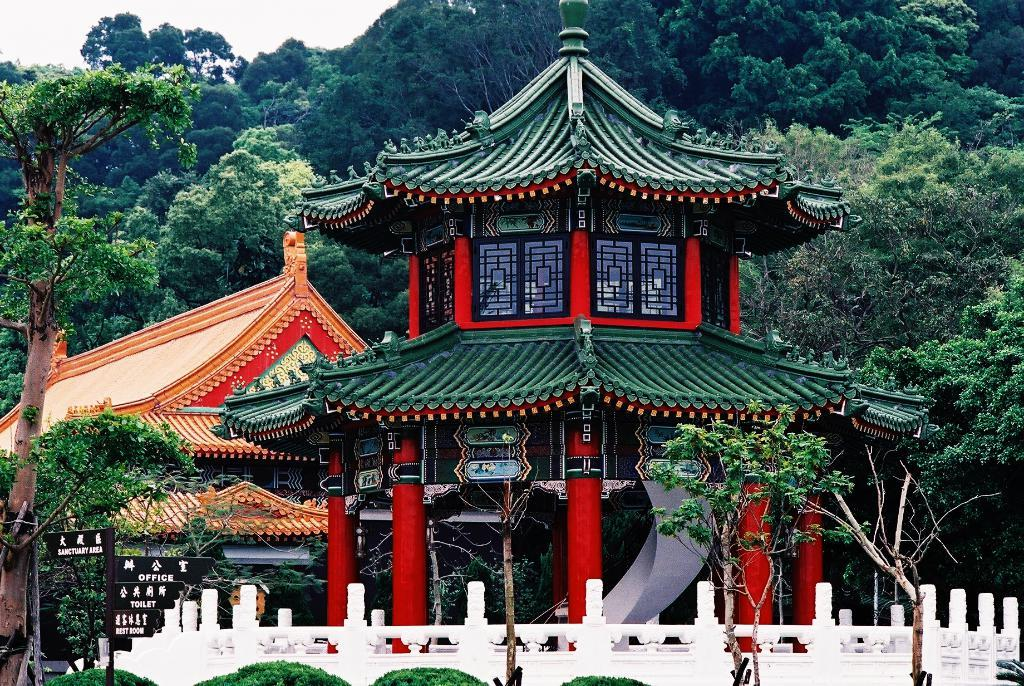What type of structures can be seen in the image? There are buildings in the image. What other natural elements are present in the image? There are trees and plants in the image. What is visible in the background of the image? There is a sky visible in the image. What can be found on the left side of the image? There are boards on the left side of the image. What color is the ink on the friend's pocket in the image? There is no friend or pocket present in the image, so there is no ink to describe. 